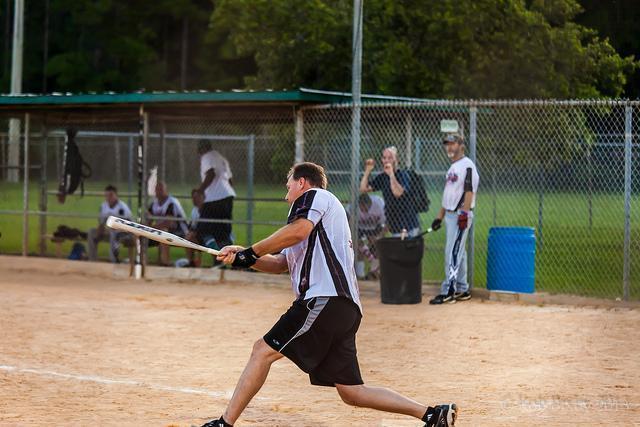What is the most common usage of the black container?
From the following set of four choices, select the accurate answer to respond to the question.
Options: Bats, garbage, dirt, drinks. Garbage. 